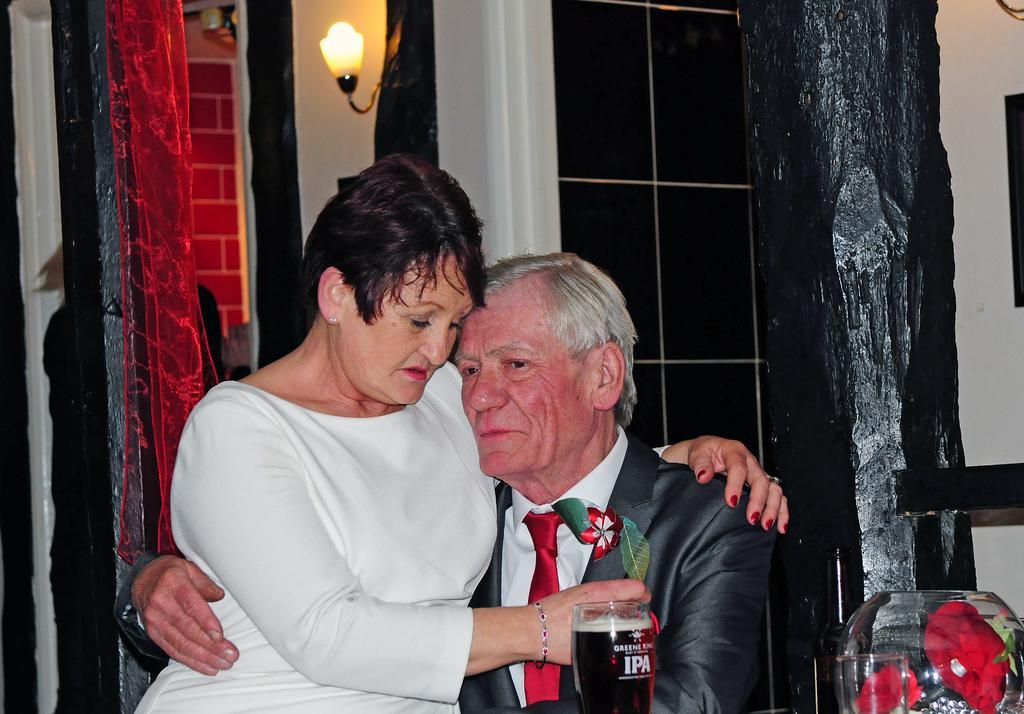Please provide a concise description of this image. In this image we can see man and a woman sitting on the chair. In the background we can see curtain, windows, electric light, walls, pillars, glass tumblers and an aquarium. 